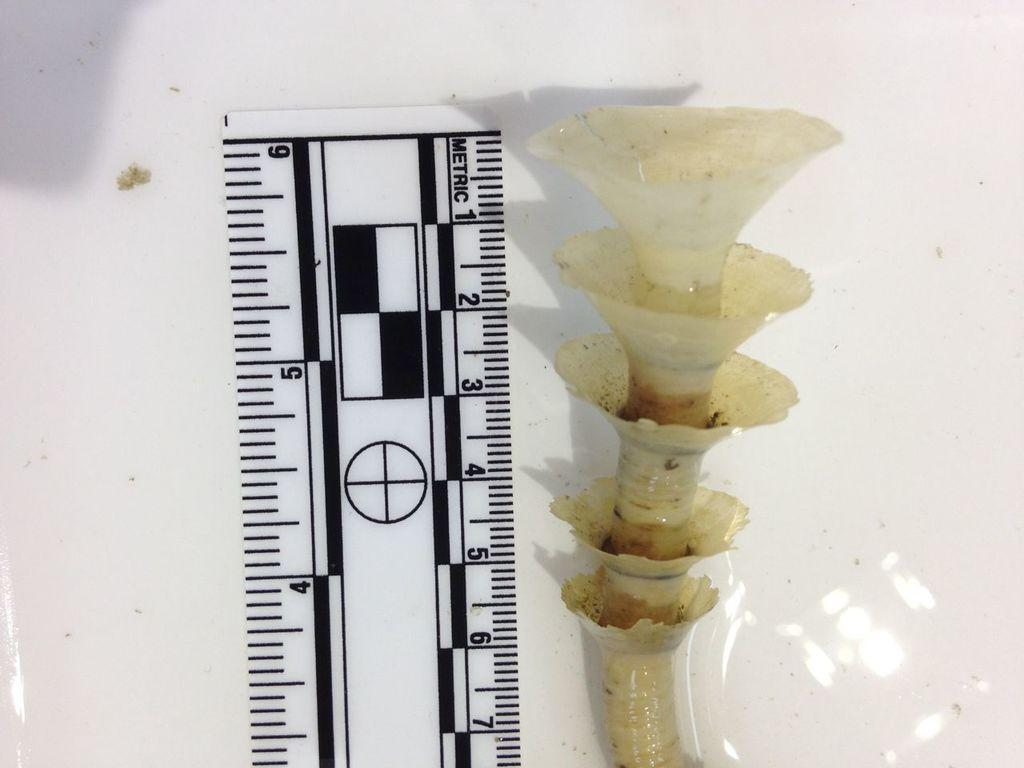Provide a one-sentence caption for the provided image. A plant appears to be at least 6 inches tall. 